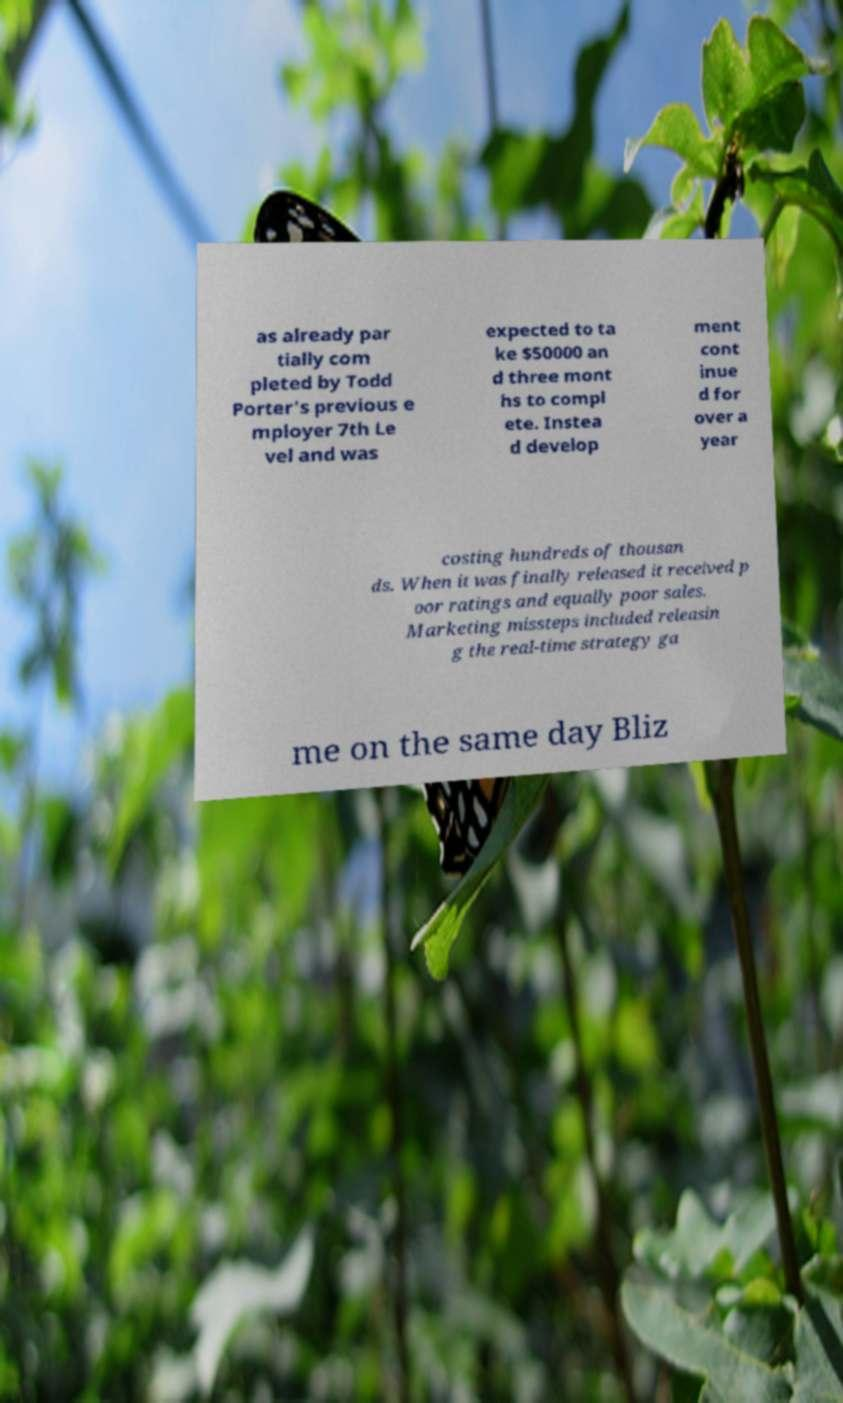Please identify and transcribe the text found in this image. as already par tially com pleted by Todd Porter's previous e mployer 7th Le vel and was expected to ta ke $50000 an d three mont hs to compl ete. Instea d develop ment cont inue d for over a year costing hundreds of thousan ds. When it was finally released it received p oor ratings and equally poor sales. Marketing missteps included releasin g the real-time strategy ga me on the same day Bliz 